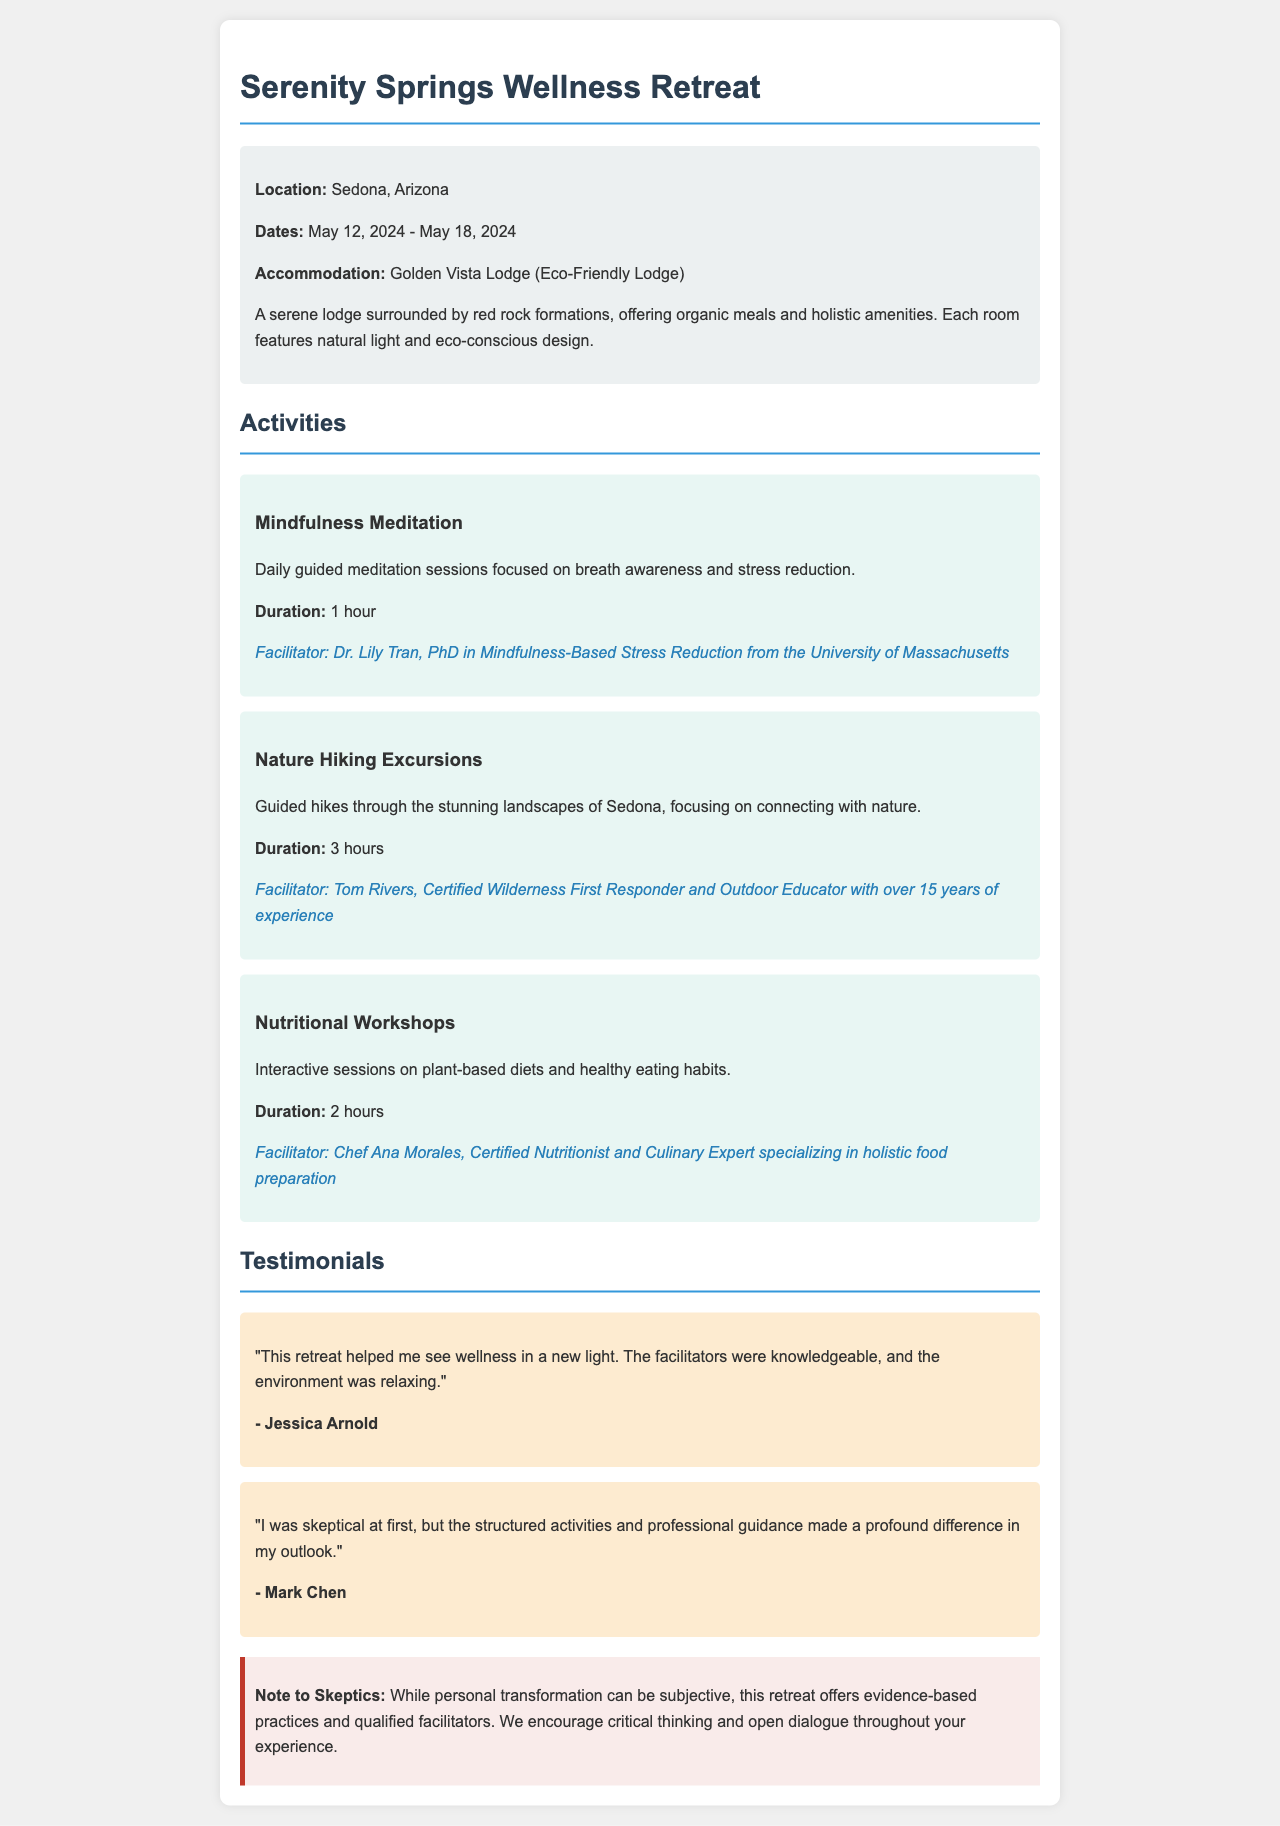What is the location of the retreat? The location of the retreat is specified in the document as Sedona, Arizona.
Answer: Sedona, Arizona What are the dates of the wellness retreat? The document indicates the dates, which are from May 12, 2024, to May 18, 2024.
Answer: May 12, 2024 - May 18, 2024 What is the name of the accommodation? The document names the accommodation as Golden Vista Lodge.
Answer: Golden Vista Lodge Who is the facilitator for Mindfulness Meditation? The facilitator for the Mindfulness Meditation activity is listed in the document as Dr. Lily Tran.
Answer: Dr. Lily Tran How long is the Nature Hiking Excursion? The duration of the Nature Hiking Excursion is provided in the document as 3 hours.
Answer: 3 hours What qualification does Tom Rivers hold? The document states that Tom Rivers is a Certified Wilderness First Responder and Outdoor Educator.
Answer: Certified Wilderness First Responder What type of meals does Golden Vista Lodge offer? The document specifies that the lodge offers organic meals.
Answer: Organic meals What does the warning note encourage? The warning note encourages critical thinking and open dialogue throughout the experience.
Answer: Critical thinking and open dialogue What is the focus of the Nutritional Workshops? The focus of the Nutritional Workshops, according to the document, is on plant-based diets and healthy eating habits.
Answer: Plant-based diets and healthy eating habits 